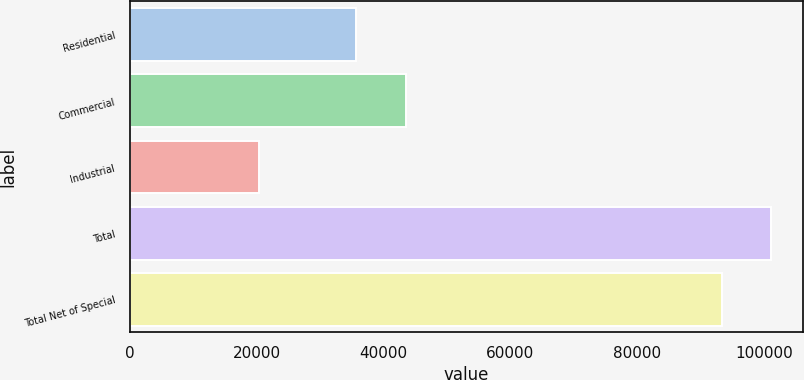Convert chart to OTSL. <chart><loc_0><loc_0><loc_500><loc_500><bar_chart><fcel>Residential<fcel>Commercial<fcel>Industrial<fcel>Total<fcel>Total Net of Special<nl><fcel>35734<fcel>43496.9<fcel>20413<fcel>101109<fcel>93346<nl></chart> 